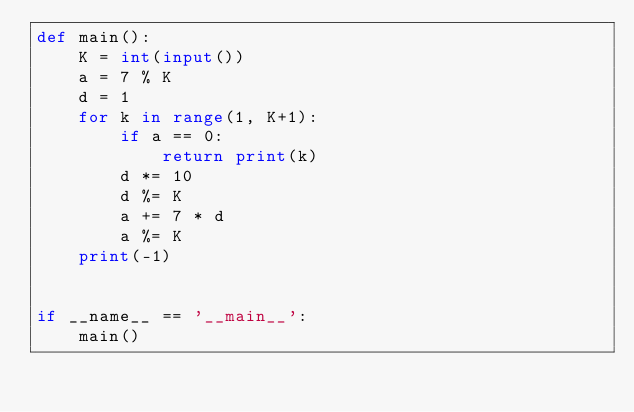<code> <loc_0><loc_0><loc_500><loc_500><_Python_>def main():
    K = int(input())
    a = 7 % K
    d = 1
    for k in range(1, K+1):
        if a == 0:
            return print(k)
        d *= 10
        d %= K
        a += 7 * d
        a %= K
    print(-1)


if __name__ == '__main__':
    main()
</code> 